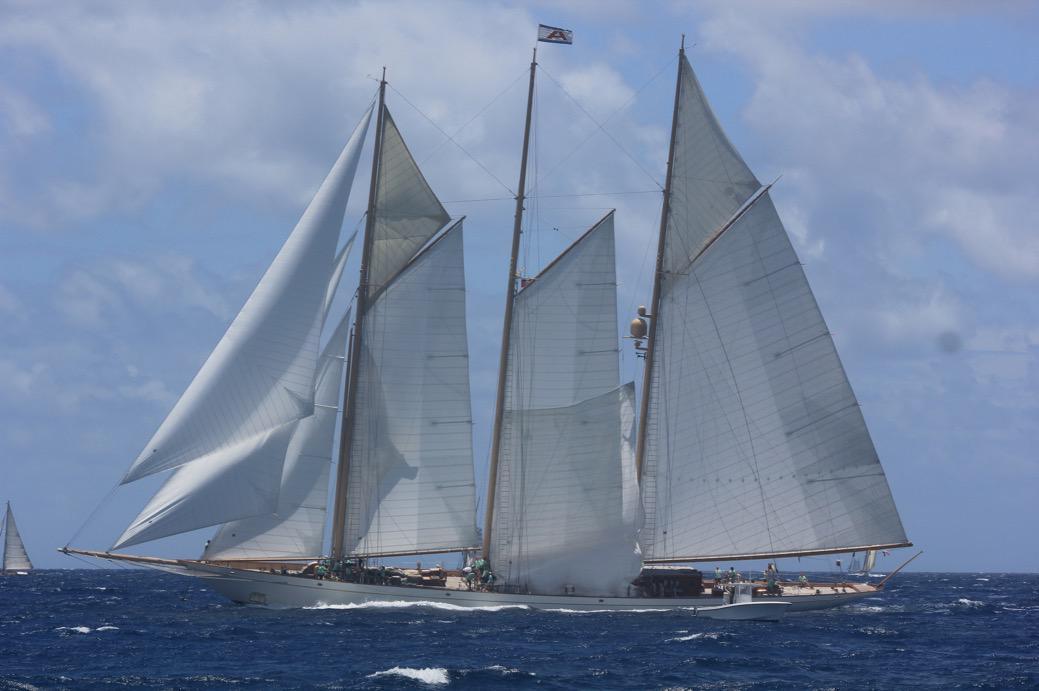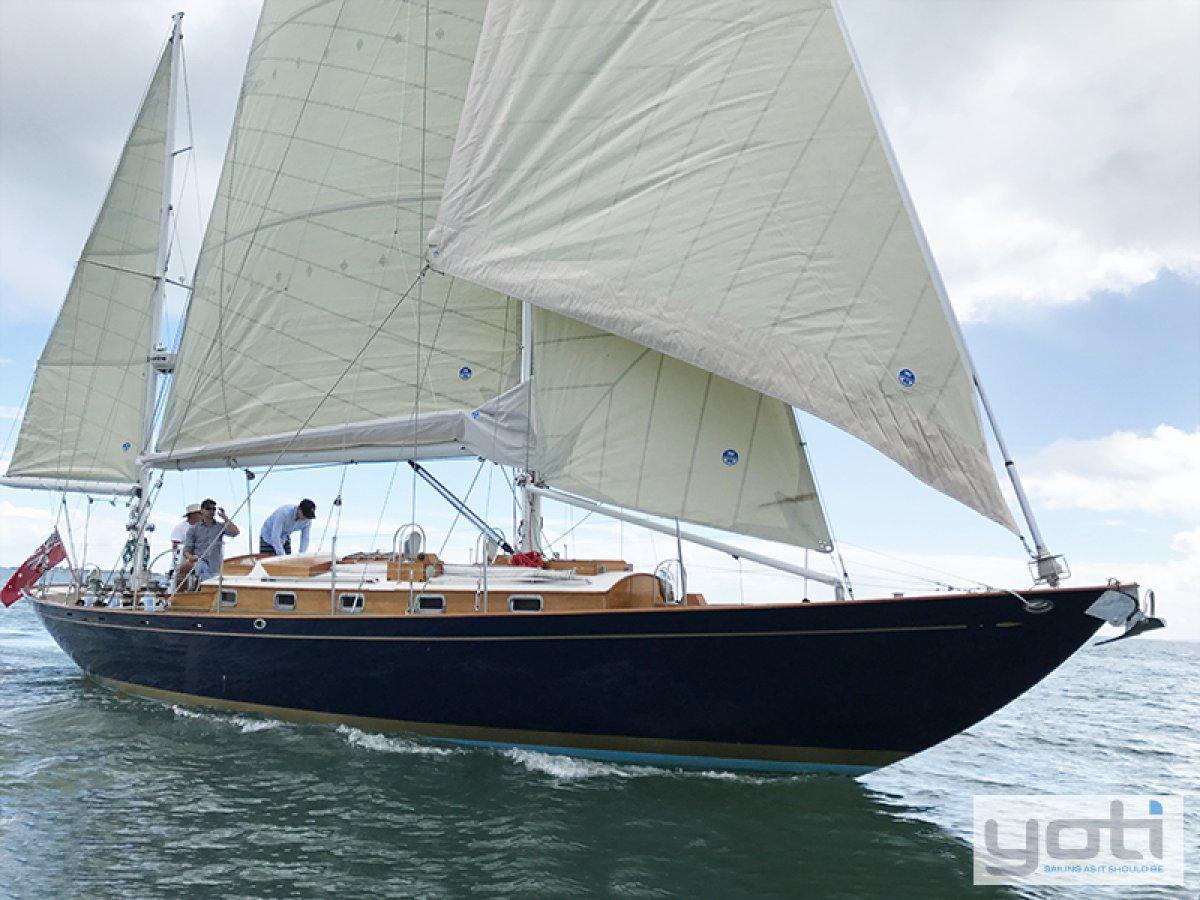The first image is the image on the left, the second image is the image on the right. For the images shown, is this caption "An image shows a dark-bodied boat with its main sail still furled." true? Answer yes or no. No. The first image is the image on the left, the second image is the image on the right. Analyze the images presented: Is the assertion "The majority of masts are furled on each sailboat." valid? Answer yes or no. No. 